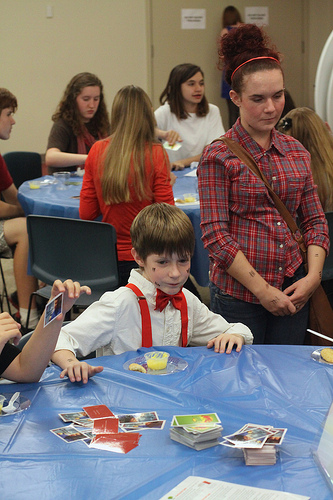<image>
Can you confirm if the girl is behind the boy? Yes. From this viewpoint, the girl is positioned behind the boy, with the boy partially or fully occluding the girl. Is there a shirt on the boy? No. The shirt is not positioned on the boy. They may be near each other, but the shirt is not supported by or resting on top of the boy. Is the cards on the wall? No. The cards is not positioned on the wall. They may be near each other, but the cards is not supported by or resting on top of the wall. Is there a woman one in front of the woman two? Yes. The woman one is positioned in front of the woman two, appearing closer to the camera viewpoint. 